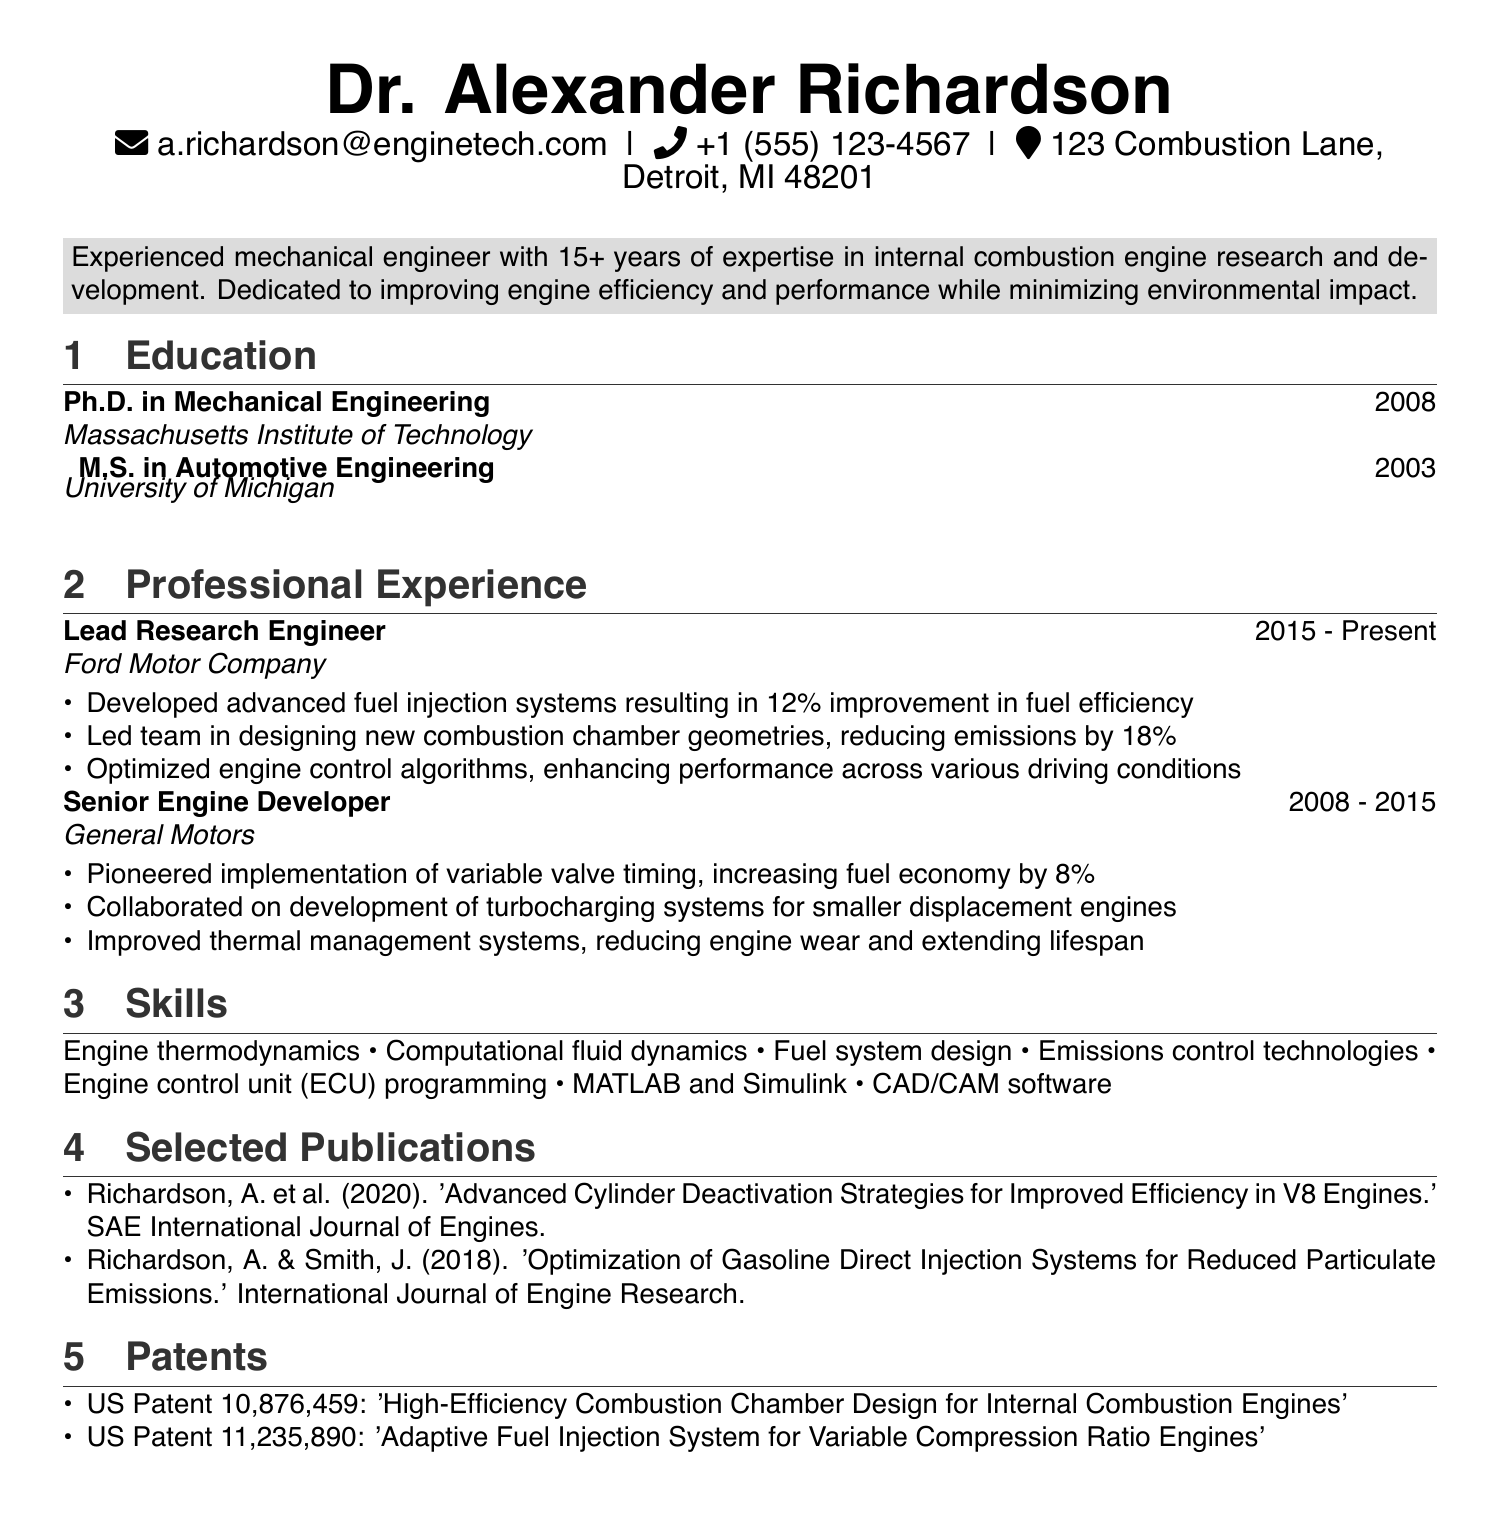what is the name of the individual? The name of the individual is presented prominently at the top of the document.
Answer: Dr. Alexander Richardson what is the degree obtained at MIT? The document lists the educational background, including degrees obtained at specific institutions.
Answer: Ph.D. in Mechanical Engineering which company does the individual work for currently? The individual's current employment status is stated in the professional experience section of the CV.
Answer: Ford Motor Company how many years of experience does the individual have in their field? The summary section provides a clear statement about the individual's years of expertise.
Answer: 15+ what was the percentage improvement in fuel efficiency due to the advanced fuel injection systems developed? The achievement details under the Lead Research Engineer position specify the quantifiable results of their work on fuel efficiency.
Answer: 12% which publication discusses cylinder deactivation strategies? The document lists selected publications, providing titles for further reference.
Answer: 'Advanced Cylinder Deactivation Strategies for Improved Efficiency in V8 Engines.' how many patents does the individual hold? The patents section enumerates the patents attributed to the individual.
Answer: 2 what is one skill mentioned related to engine system design? The skills section lists technical competencies relevant to the individual's expertise.
Answer: Fuel system design what year did the individual complete their master's degree? The education section details the years of graduation for each degree.
Answer: 2003 